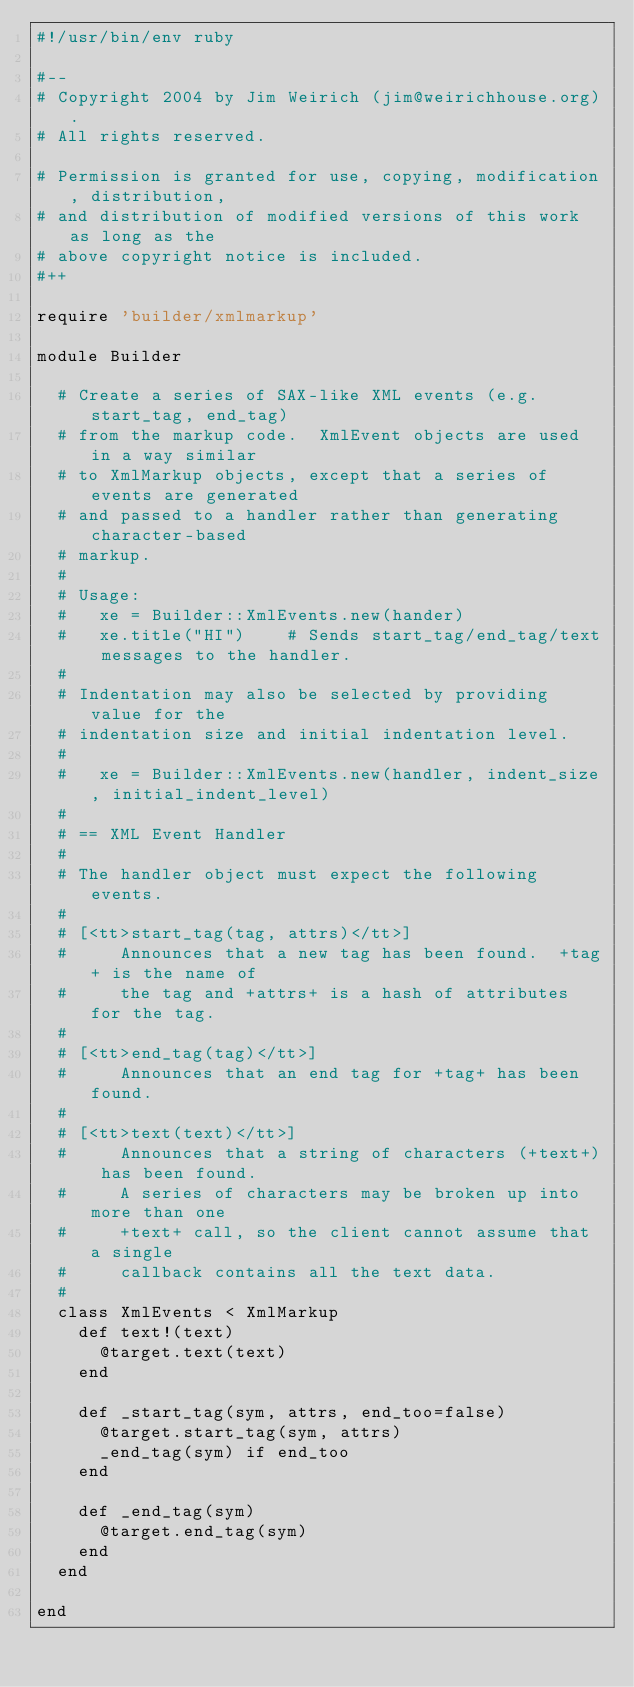Convert code to text. <code><loc_0><loc_0><loc_500><loc_500><_Ruby_>#!/usr/bin/env ruby

#--
# Copyright 2004 by Jim Weirich (jim@weirichhouse.org).
# All rights reserved.

# Permission is granted for use, copying, modification, distribution,
# and distribution of modified versions of this work as long as the
# above copyright notice is included.
#++

require 'builder/xmlmarkup'

module Builder

  # Create a series of SAX-like XML events (e.g. start_tag, end_tag)
  # from the markup code.  XmlEvent objects are used in a way similar
  # to XmlMarkup objects, except that a series of events are generated
  # and passed to a handler rather than generating character-based
  # markup.
  #
  # Usage:
  #   xe = Builder::XmlEvents.new(hander)
  #   xe.title("HI")    # Sends start_tag/end_tag/text messages to the handler.
  #
  # Indentation may also be selected by providing value for the
  # indentation size and initial indentation level.
  #
  #   xe = Builder::XmlEvents.new(handler, indent_size, initial_indent_level)
  #
  # == XML Event Handler
  #
  # The handler object must expect the following events.
  #
  # [<tt>start_tag(tag, attrs)</tt>]
  #     Announces that a new tag has been found.  +tag+ is the name of
  #     the tag and +attrs+ is a hash of attributes for the tag.
  #
  # [<tt>end_tag(tag)</tt>]
  #     Announces that an end tag for +tag+ has been found.
  #
  # [<tt>text(text)</tt>]
  #     Announces that a string of characters (+text+) has been found.
  #     A series of characters may be broken up into more than one
  #     +text+ call, so the client cannot assume that a single
  #     callback contains all the text data.
  #
  class XmlEvents < XmlMarkup
    def text!(text)
      @target.text(text)
    end

    def _start_tag(sym, attrs, end_too=false)
      @target.start_tag(sym, attrs)
      _end_tag(sym) if end_too
    end

    def _end_tag(sym)
      @target.end_tag(sym)
    end
  end

end
</code> 